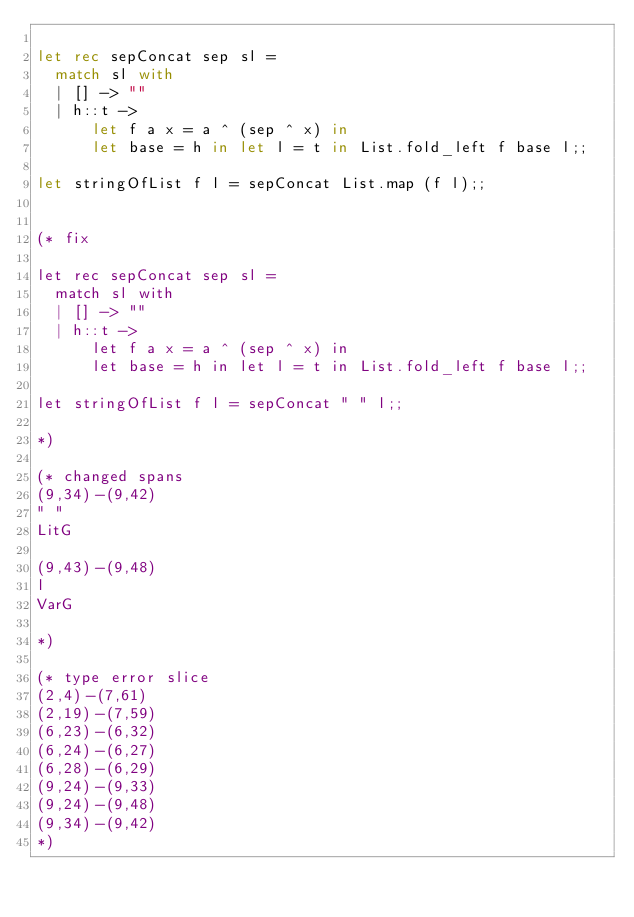<code> <loc_0><loc_0><loc_500><loc_500><_OCaml_>
let rec sepConcat sep sl =
  match sl with
  | [] -> ""
  | h::t ->
      let f a x = a ^ (sep ^ x) in
      let base = h in let l = t in List.fold_left f base l;;

let stringOfList f l = sepConcat List.map (f l);;


(* fix

let rec sepConcat sep sl =
  match sl with
  | [] -> ""
  | h::t ->
      let f a x = a ^ (sep ^ x) in
      let base = h in let l = t in List.fold_left f base l;;

let stringOfList f l = sepConcat " " l;;

*)

(* changed spans
(9,34)-(9,42)
" "
LitG

(9,43)-(9,48)
l
VarG

*)

(* type error slice
(2,4)-(7,61)
(2,19)-(7,59)
(6,23)-(6,32)
(6,24)-(6,27)
(6,28)-(6,29)
(9,24)-(9,33)
(9,24)-(9,48)
(9,34)-(9,42)
*)
</code> 